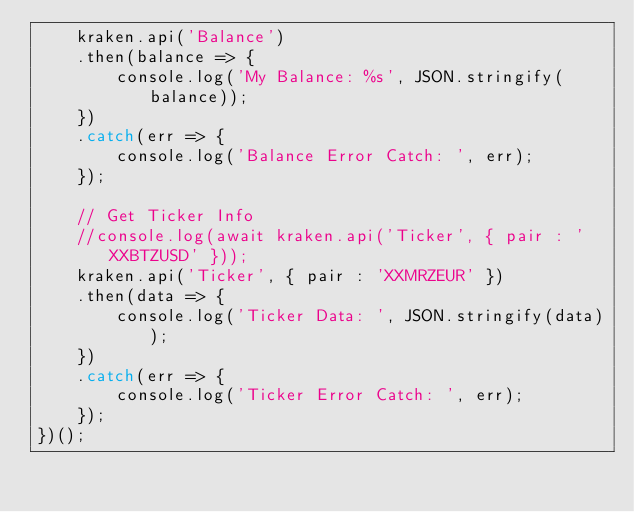Convert code to text. <code><loc_0><loc_0><loc_500><loc_500><_JavaScript_>    kraken.api('Balance')
	.then(balance => {
	    console.log('My Balance: %s', JSON.stringify(balance));
	})
    .catch(err => {
    	console.log('Balance Error Catch: ', err);
    });
 
    // Get Ticker Info
    //console.log(await kraken.api('Ticker', { pair : 'XXBTZUSD' }));
    kraken.api('Ticker', { pair : 'XXMRZEUR' })
    .then(data => {
		console.log('Ticker Data: ', JSON.stringify(data));
    })
    .catch(err => {
    	console.log('Ticker Error Catch: ', err);
    });
})();
</code> 